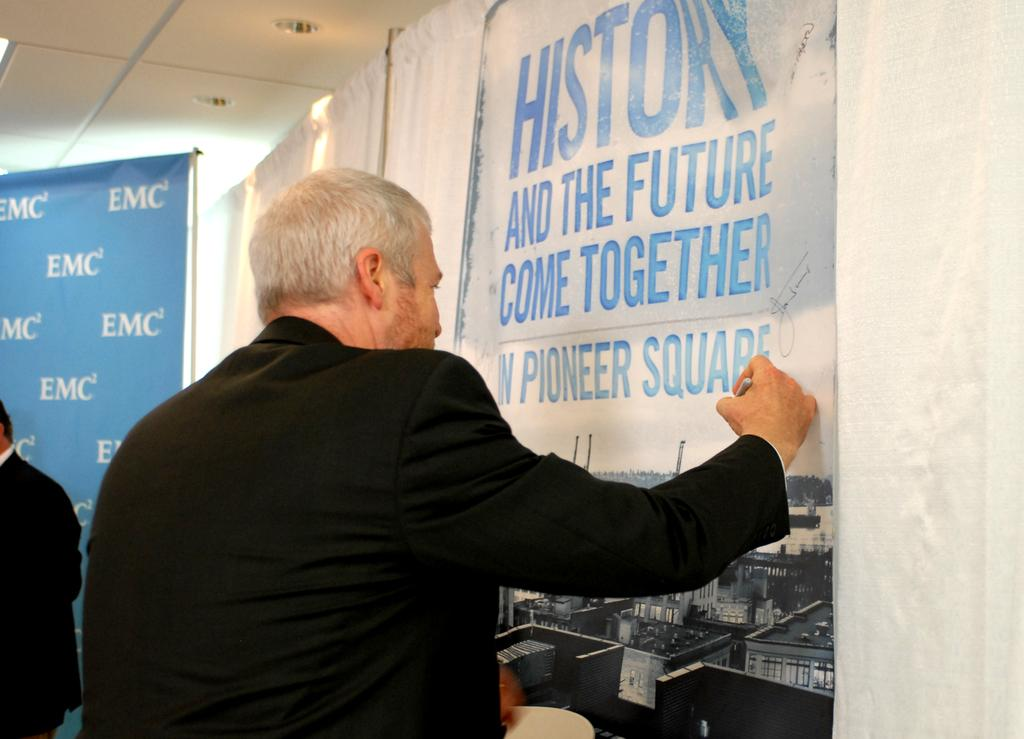<image>
Present a compact description of the photo's key features. A grey haired man in a black jacket writes on a banner that reads "History and the future come together." 